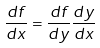Convert formula to latex. <formula><loc_0><loc_0><loc_500><loc_500>\frac { d f } { d x } = \frac { d f } { d y } \frac { d y } { d x }</formula> 